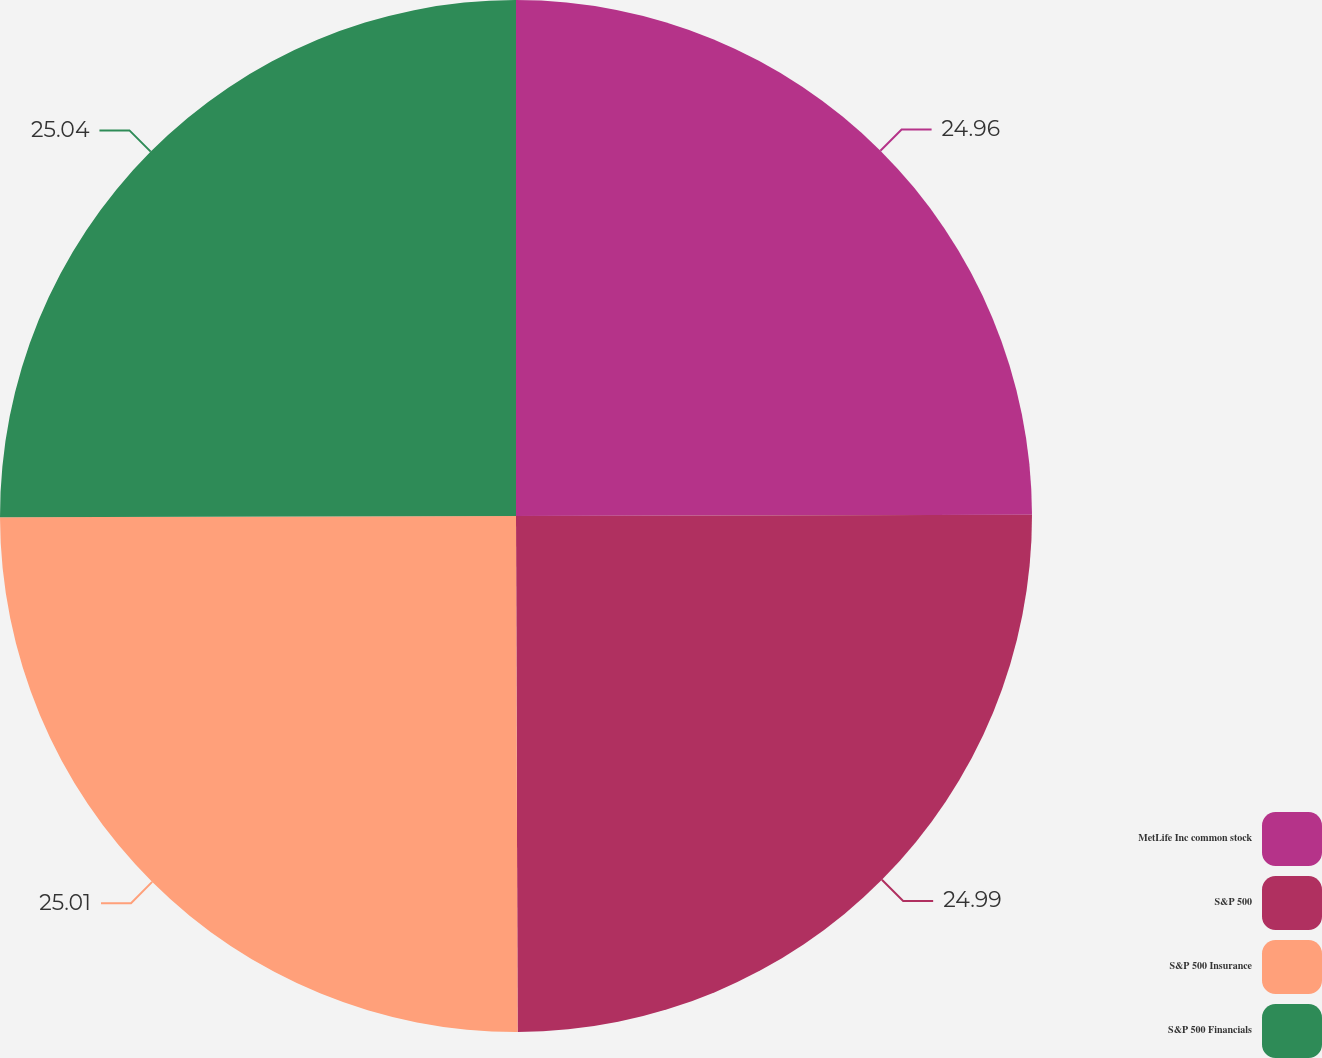Convert chart. <chart><loc_0><loc_0><loc_500><loc_500><pie_chart><fcel>MetLife Inc common stock<fcel>S&P 500<fcel>S&P 500 Insurance<fcel>S&P 500 Financials<nl><fcel>24.96%<fcel>24.99%<fcel>25.01%<fcel>25.04%<nl></chart> 